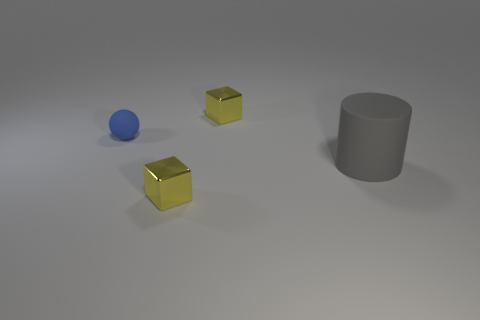Add 1 big brown cylinders. How many objects exist? 5 Subtract all cylinders. How many objects are left? 3 Subtract all cyan cylinders. Subtract all brown cubes. How many cylinders are left? 1 Subtract all cyan balls. How many green cubes are left? 0 Subtract all big matte things. Subtract all cubes. How many objects are left? 1 Add 1 tiny blue matte spheres. How many tiny blue matte spheres are left? 2 Add 4 small blue balls. How many small blue balls exist? 5 Subtract 0 brown spheres. How many objects are left? 4 